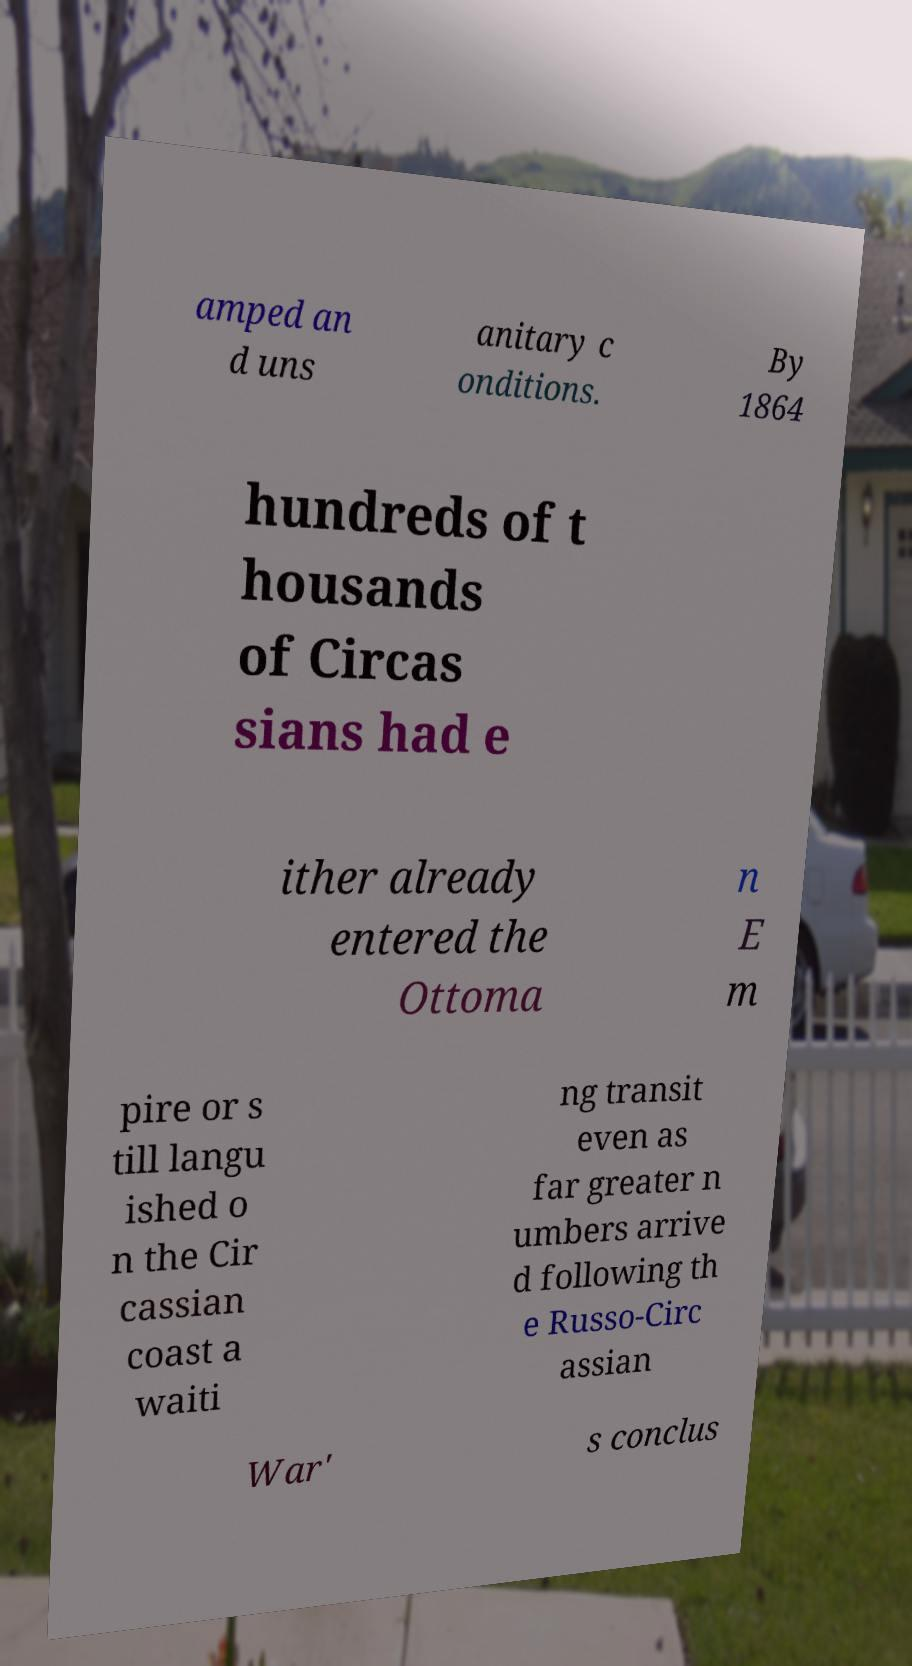Could you assist in decoding the text presented in this image and type it out clearly? amped an d uns anitary c onditions. By 1864 hundreds of t housands of Circas sians had e ither already entered the Ottoma n E m pire or s till langu ished o n the Cir cassian coast a waiti ng transit even as far greater n umbers arrive d following th e Russo-Circ assian War' s conclus 